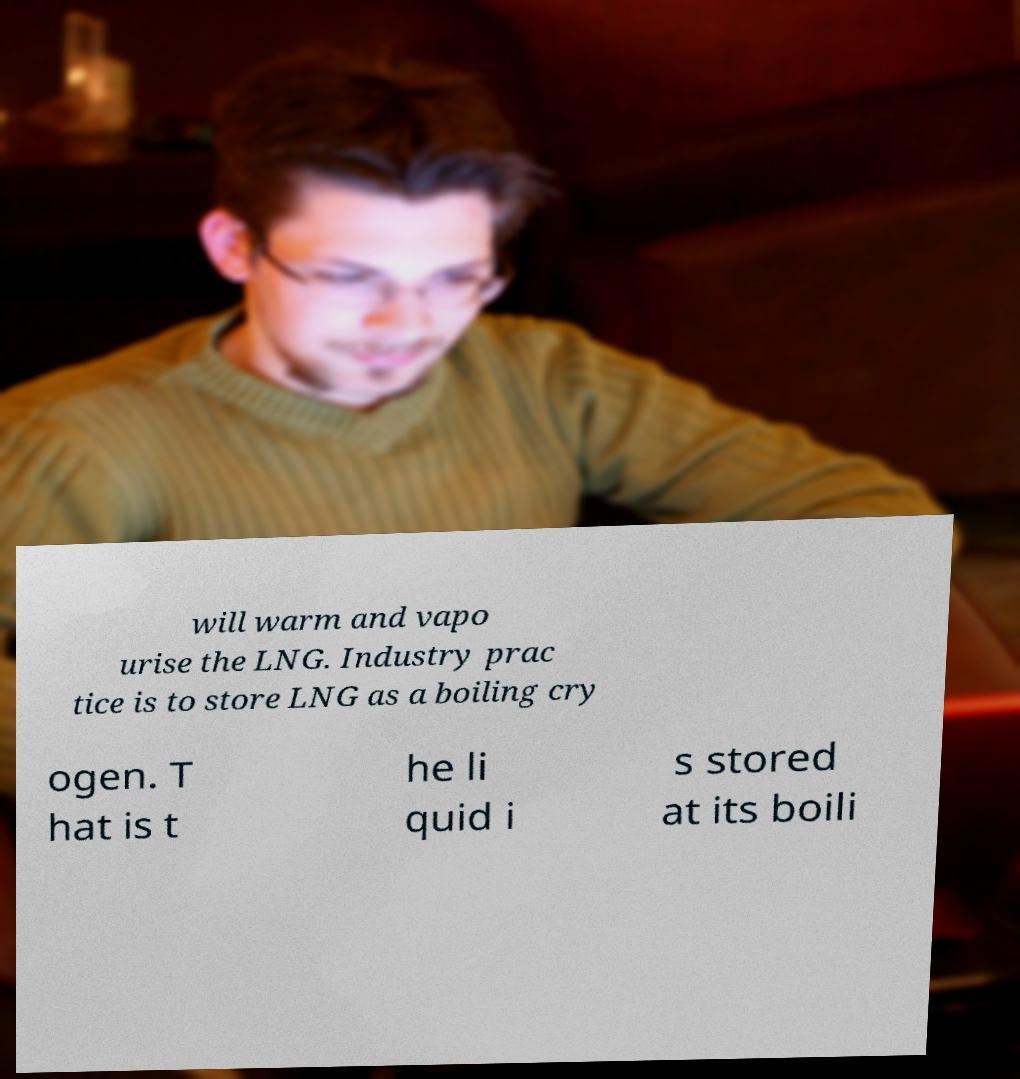There's text embedded in this image that I need extracted. Can you transcribe it verbatim? will warm and vapo urise the LNG. Industry prac tice is to store LNG as a boiling cry ogen. T hat is t he li quid i s stored at its boili 